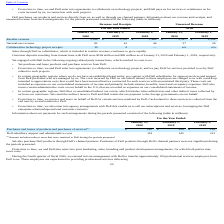From Vmware's financial document, Which years does the table provide information for the company's payment arrangements? The document contains multiple relevant values: 2020, 2019, 2018. From the document: "2020 2019 2018 2020 2019 2020 2019 2018 2020 2019 2020 2019 2018 2020 2019..." Also, What does Purchases and leases of products and purchases of services include? indirect taxes that were remitted to Dell during the periods presented. The document states: "(1) Amount includes indirect taxes that were remitted to Dell during the periods presented...." Also, What was the Dell subsidiary support and administrative costs in 2019? According to the financial document, 145 (in millions). The relevant text states: "l subsidiary support and administrative costs 119 145 212..." Also, can you calculate: What was the change in Purchases and leases of products and purchases of services between 2018 and 2019? Based on the calculation: 200-142, the result is 58 (in millions). This is based on the information: "ducts and purchases of services (1) $ 242 $ 200 $ 142 of products and purchases of services (1) $ 242 $ 200 $ 142..." The key data points involved are: 142, 200. Also, How many years did Dell subsidiary support and administrative costs exceed $200 million? Based on the analysis, there are 1 instances. The counting process: 2018. Also, can you calculate: What was the percentage change in the Dell subsidiary support and administrative costs between 2019 and 2020? To answer this question, I need to perform calculations using the financial data. The calculation is: (119-145)/145, which equals -17.93 (percentage). This is based on the information: "l subsidiary support and administrative costs 119 145 212 Dell subsidiary support and administrative costs 119 145 212..." The key data points involved are: 119, 145. 